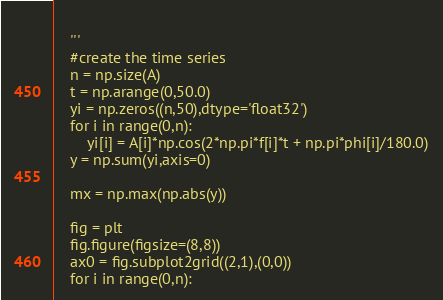<code> <loc_0><loc_0><loc_500><loc_500><_Python_>	 
	'''
	#create the time series
	n = np.size(A)
	t = np.arange(0,50.0)
	yi = np.zeros((n,50),dtype='float32')
	for i in range(0,n):
		yi[i] = A[i]*np.cos(2*np.pi*f[i]*t + np.pi*phi[i]/180.0)
	y = np.sum(yi,axis=0)
	
	mx = np.max(np.abs(y))
	
	fig = plt
	fig.figure(figsize=(8,8))
	ax0 = fig.subplot2grid((2,1),(0,0))
	for i in range(0,n):</code> 